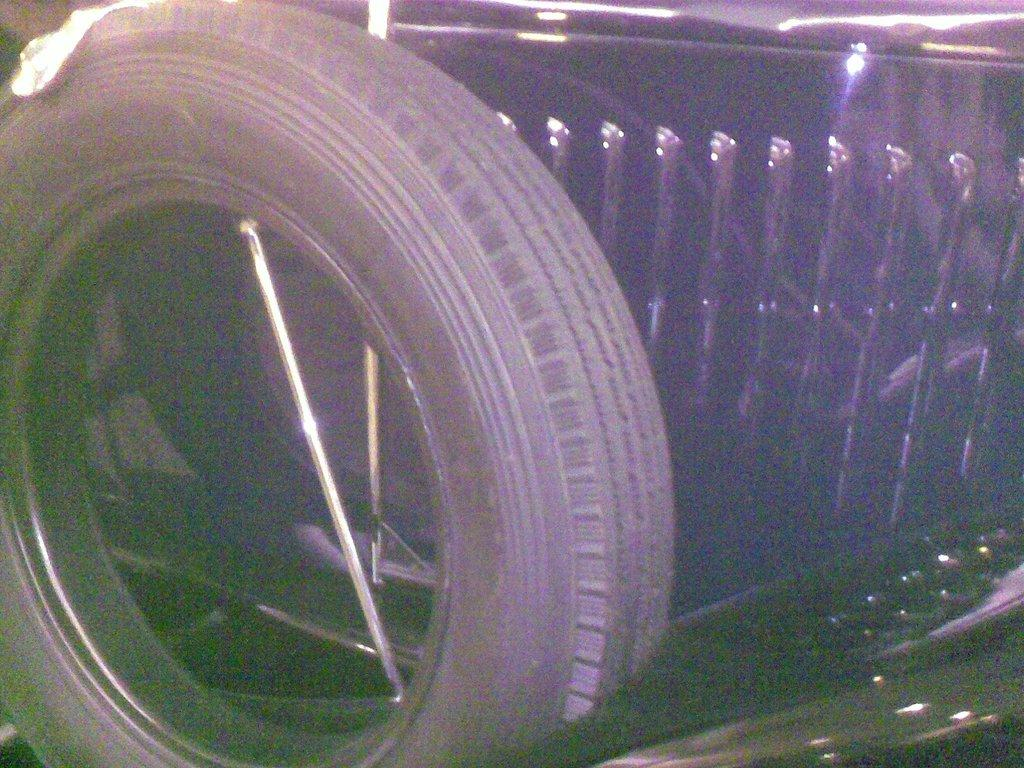What type of object is in the image? There is a vehicle in the image. Where is the vehicle located? The vehicle is on the ground. What other object can be seen in the image? There is an iron rod in the image. How is the iron rod positioned in relation to the vehicle? The iron rod is placed between the vehicle's tires. How does the vehicle aid in the digestion process of the deer in the image? There are no deer present in the image, and the vehicle is not involved in any digestion process. 